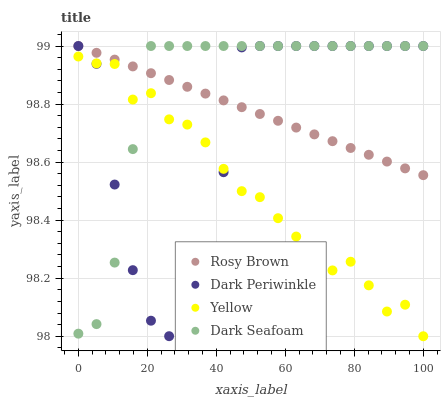Does Yellow have the minimum area under the curve?
Answer yes or no. Yes. Does Dark Seafoam have the maximum area under the curve?
Answer yes or no. Yes. Does Rosy Brown have the minimum area under the curve?
Answer yes or no. No. Does Rosy Brown have the maximum area under the curve?
Answer yes or no. No. Is Rosy Brown the smoothest?
Answer yes or no. Yes. Is Dark Periwinkle the roughest?
Answer yes or no. Yes. Is Dark Periwinkle the smoothest?
Answer yes or no. No. Is Rosy Brown the roughest?
Answer yes or no. No. Does Yellow have the lowest value?
Answer yes or no. Yes. Does Dark Periwinkle have the lowest value?
Answer yes or no. No. Does Dark Periwinkle have the highest value?
Answer yes or no. Yes. Does Yellow have the highest value?
Answer yes or no. No. Is Yellow less than Rosy Brown?
Answer yes or no. Yes. Is Rosy Brown greater than Yellow?
Answer yes or no. Yes. Does Dark Seafoam intersect Dark Periwinkle?
Answer yes or no. Yes. Is Dark Seafoam less than Dark Periwinkle?
Answer yes or no. No. Is Dark Seafoam greater than Dark Periwinkle?
Answer yes or no. No. Does Yellow intersect Rosy Brown?
Answer yes or no. No. 